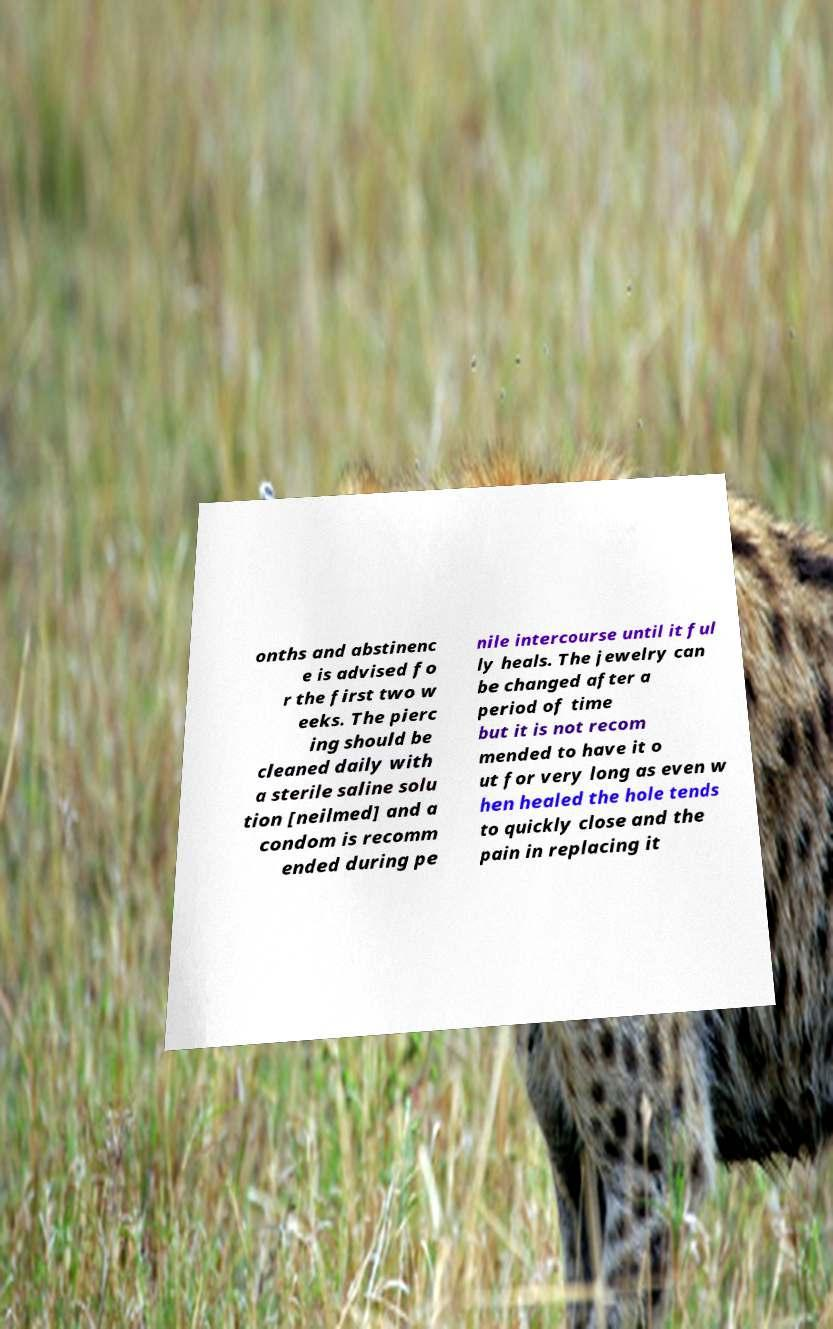What messages or text are displayed in this image? I need them in a readable, typed format. onths and abstinenc e is advised fo r the first two w eeks. The pierc ing should be cleaned daily with a sterile saline solu tion [neilmed] and a condom is recomm ended during pe nile intercourse until it ful ly heals. The jewelry can be changed after a period of time but it is not recom mended to have it o ut for very long as even w hen healed the hole tends to quickly close and the pain in replacing it 